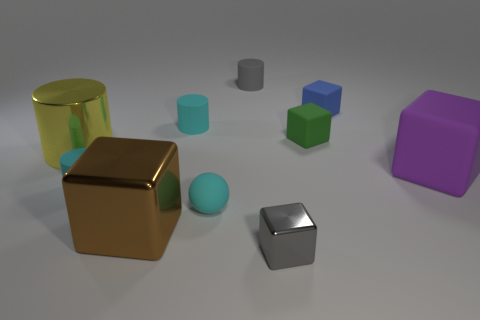Are there any small cyan matte balls right of the blue thing?
Offer a very short reply. No. What is the large cylinder made of?
Make the answer very short. Metal. Do the big metallic object in front of the yellow metal thing and the rubber sphere have the same color?
Give a very brief answer. No. Is there any other thing that has the same shape as the blue rubber object?
Your answer should be compact. Yes. The shiny object that is the same shape as the gray matte thing is what color?
Give a very brief answer. Yellow. What material is the cyan cylinder in front of the big yellow metallic object?
Provide a succinct answer. Rubber. The rubber sphere is what color?
Provide a short and direct response. Cyan. Do the block that is to the right of the blue thing and the small green object have the same size?
Your answer should be compact. No. What material is the tiny gray thing on the left side of the block that is in front of the shiny block to the left of the rubber ball made of?
Provide a succinct answer. Rubber. Does the tiny cylinder left of the brown thing have the same color as the small block that is in front of the big yellow cylinder?
Ensure brevity in your answer.  No. 